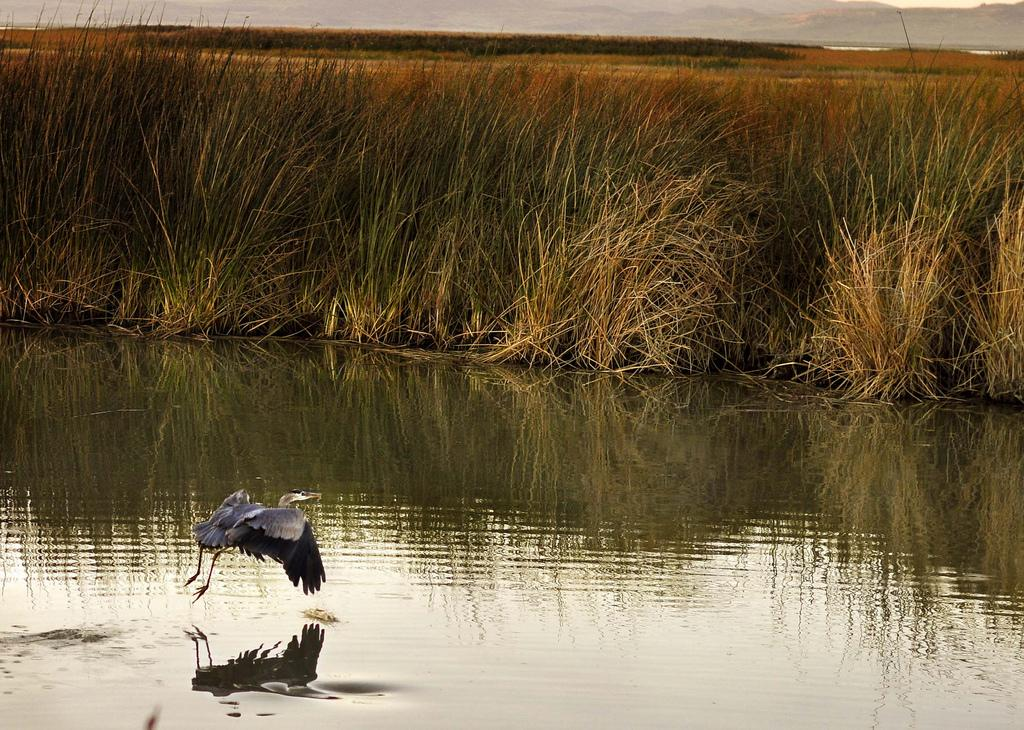What is the bird in the image doing? The bird is flying in the air. What else can be seen in the image besides the bird? Water, the reflection of a bird on the water, grass, and the sky are visible in the image. What is the bird's reflection on? The bird's reflection is visible on the water. What type of vegetation is in the background of the image? Grass is in the background of the image. What is visible in the sky in the image? The sky is visible in the background of the image. How far away is the town from the bird in the image? There is no town present in the image, so it is not possible to determine the distance between the bird and a town. 